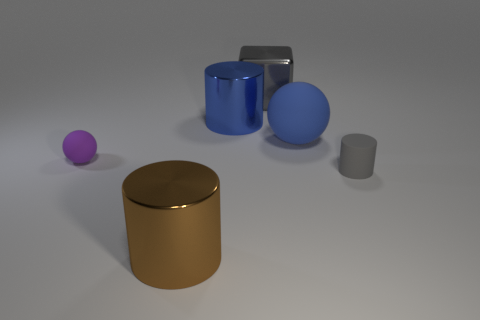Add 3 purple rubber things. How many objects exist? 9 Subtract all spheres. How many objects are left? 4 Add 6 tiny purple things. How many tiny purple things exist? 7 Subtract 1 gray cubes. How many objects are left? 5 Subtract all tiny cubes. Subtract all small purple rubber objects. How many objects are left? 5 Add 6 cylinders. How many cylinders are left? 9 